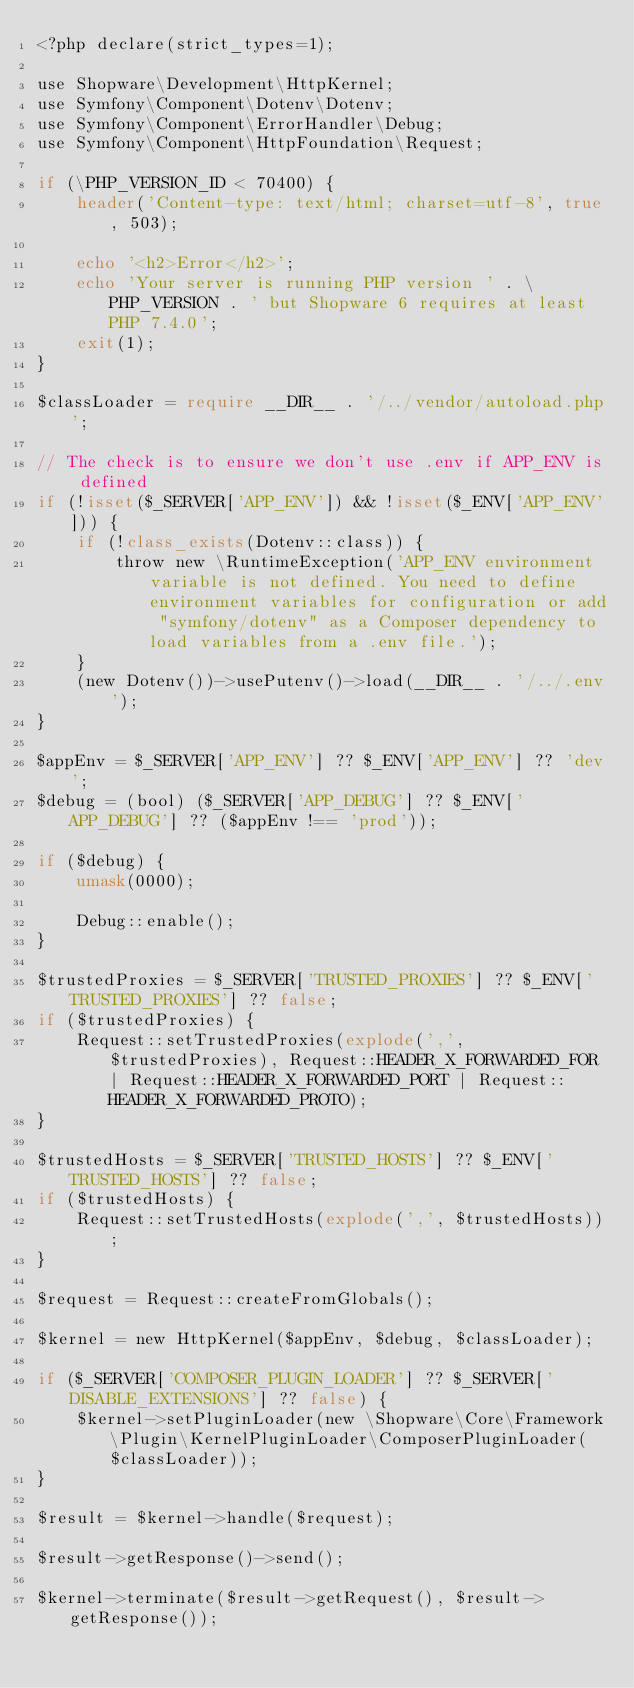Convert code to text. <code><loc_0><loc_0><loc_500><loc_500><_PHP_><?php declare(strict_types=1);

use Shopware\Development\HttpKernel;
use Symfony\Component\Dotenv\Dotenv;
use Symfony\Component\ErrorHandler\Debug;
use Symfony\Component\HttpFoundation\Request;

if (\PHP_VERSION_ID < 70400) {
    header('Content-type: text/html; charset=utf-8', true, 503);

    echo '<h2>Error</h2>';
    echo 'Your server is running PHP version ' . \PHP_VERSION . ' but Shopware 6 requires at least PHP 7.4.0';
    exit(1);
}

$classLoader = require __DIR__ . '/../vendor/autoload.php';

// The check is to ensure we don't use .env if APP_ENV is defined
if (!isset($_SERVER['APP_ENV']) && !isset($_ENV['APP_ENV'])) {
    if (!class_exists(Dotenv::class)) {
        throw new \RuntimeException('APP_ENV environment variable is not defined. You need to define environment variables for configuration or add "symfony/dotenv" as a Composer dependency to load variables from a .env file.');
    }
    (new Dotenv())->usePutenv()->load(__DIR__ . '/../.env');
}

$appEnv = $_SERVER['APP_ENV'] ?? $_ENV['APP_ENV'] ?? 'dev';
$debug = (bool) ($_SERVER['APP_DEBUG'] ?? $_ENV['APP_DEBUG'] ?? ($appEnv !== 'prod'));

if ($debug) {
    umask(0000);

    Debug::enable();
}

$trustedProxies = $_SERVER['TRUSTED_PROXIES'] ?? $_ENV['TRUSTED_PROXIES'] ?? false;
if ($trustedProxies) {
    Request::setTrustedProxies(explode(',', $trustedProxies), Request::HEADER_X_FORWARDED_FOR | Request::HEADER_X_FORWARDED_PORT | Request::HEADER_X_FORWARDED_PROTO);
}

$trustedHosts = $_SERVER['TRUSTED_HOSTS'] ?? $_ENV['TRUSTED_HOSTS'] ?? false;
if ($trustedHosts) {
    Request::setTrustedHosts(explode(',', $trustedHosts));
}

$request = Request::createFromGlobals();

$kernel = new HttpKernel($appEnv, $debug, $classLoader);

if ($_SERVER['COMPOSER_PLUGIN_LOADER'] ?? $_SERVER['DISABLE_EXTENSIONS'] ?? false) {
    $kernel->setPluginLoader(new \Shopware\Core\Framework\Plugin\KernelPluginLoader\ComposerPluginLoader($classLoader));
}

$result = $kernel->handle($request);

$result->getResponse()->send();

$kernel->terminate($result->getRequest(), $result->getResponse());
</code> 